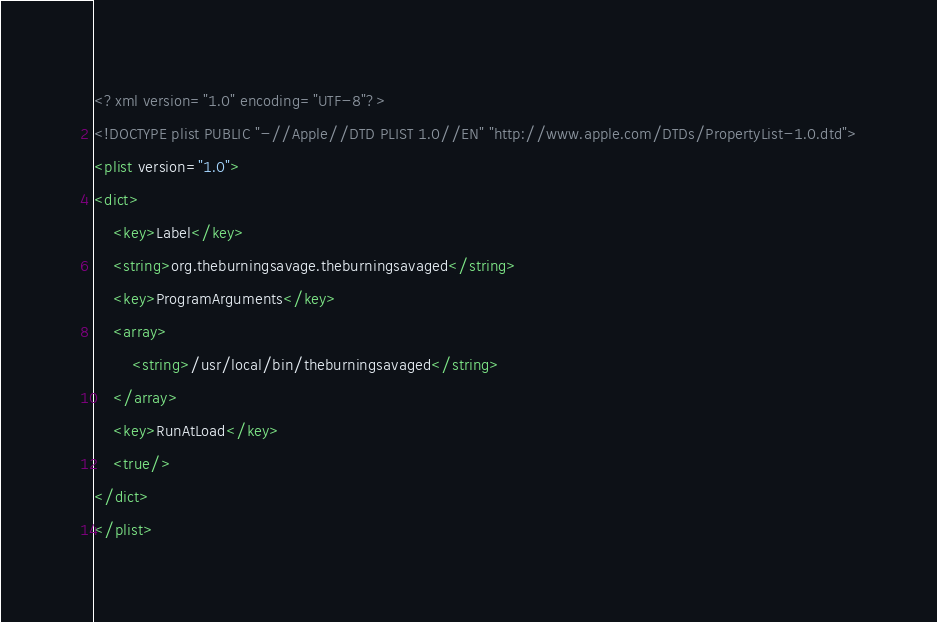<code> <loc_0><loc_0><loc_500><loc_500><_XML_><?xml version="1.0" encoding="UTF-8"?>
<!DOCTYPE plist PUBLIC "-//Apple//DTD PLIST 1.0//EN" "http://www.apple.com/DTDs/PropertyList-1.0.dtd">
<plist version="1.0">
<dict>
	<key>Label</key>
	<string>org.theburningsavage.theburningsavaged</string>
	<key>ProgramArguments</key>
	<array>
		<string>/usr/local/bin/theburningsavaged</string>
	</array>
	<key>RunAtLoad</key>
	<true/>
</dict>
</plist>
</code> 